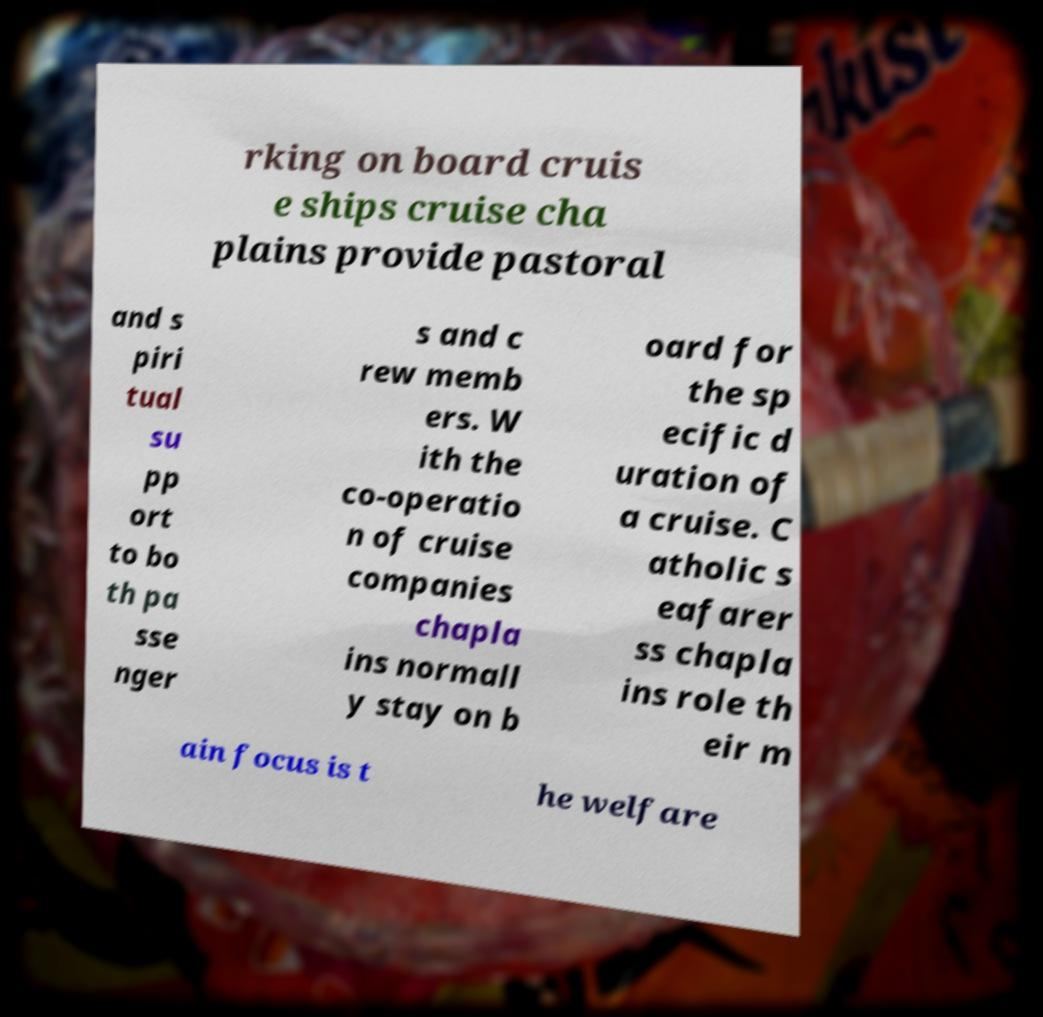Could you extract and type out the text from this image? rking on board cruis e ships cruise cha plains provide pastoral and s piri tual su pp ort to bo th pa sse nger s and c rew memb ers. W ith the co-operatio n of cruise companies chapla ins normall y stay on b oard for the sp ecific d uration of a cruise. C atholic s eafarer ss chapla ins role th eir m ain focus is t he welfare 